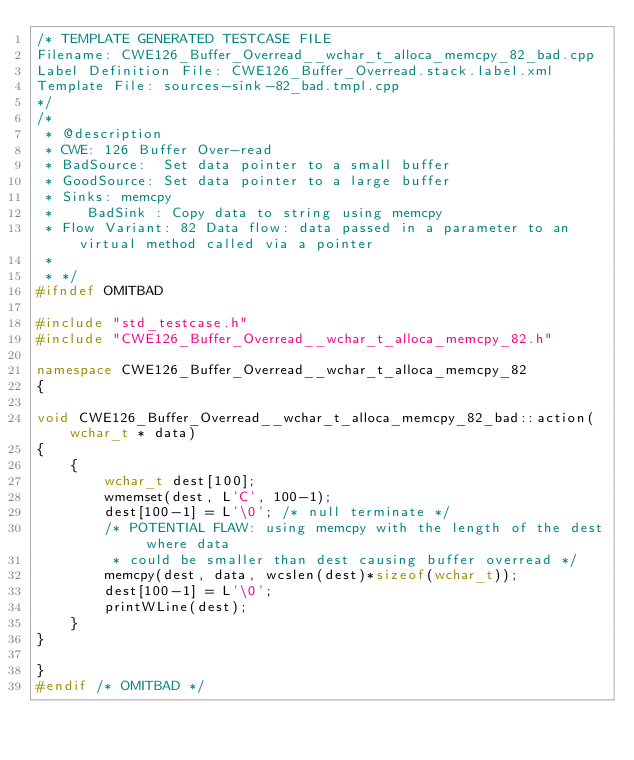Convert code to text. <code><loc_0><loc_0><loc_500><loc_500><_C++_>/* TEMPLATE GENERATED TESTCASE FILE
Filename: CWE126_Buffer_Overread__wchar_t_alloca_memcpy_82_bad.cpp
Label Definition File: CWE126_Buffer_Overread.stack.label.xml
Template File: sources-sink-82_bad.tmpl.cpp
*/
/*
 * @description
 * CWE: 126 Buffer Over-read
 * BadSource:  Set data pointer to a small buffer
 * GoodSource: Set data pointer to a large buffer
 * Sinks: memcpy
 *    BadSink : Copy data to string using memcpy
 * Flow Variant: 82 Data flow: data passed in a parameter to an virtual method called via a pointer
 *
 * */
#ifndef OMITBAD

#include "std_testcase.h"
#include "CWE126_Buffer_Overread__wchar_t_alloca_memcpy_82.h"

namespace CWE126_Buffer_Overread__wchar_t_alloca_memcpy_82
{

void CWE126_Buffer_Overread__wchar_t_alloca_memcpy_82_bad::action(wchar_t * data)
{
    {
        wchar_t dest[100];
        wmemset(dest, L'C', 100-1);
        dest[100-1] = L'\0'; /* null terminate */
        /* POTENTIAL FLAW: using memcpy with the length of the dest where data
         * could be smaller than dest causing buffer overread */
        memcpy(dest, data, wcslen(dest)*sizeof(wchar_t));
        dest[100-1] = L'\0';
        printWLine(dest);
    }
}

}
#endif /* OMITBAD */
</code> 